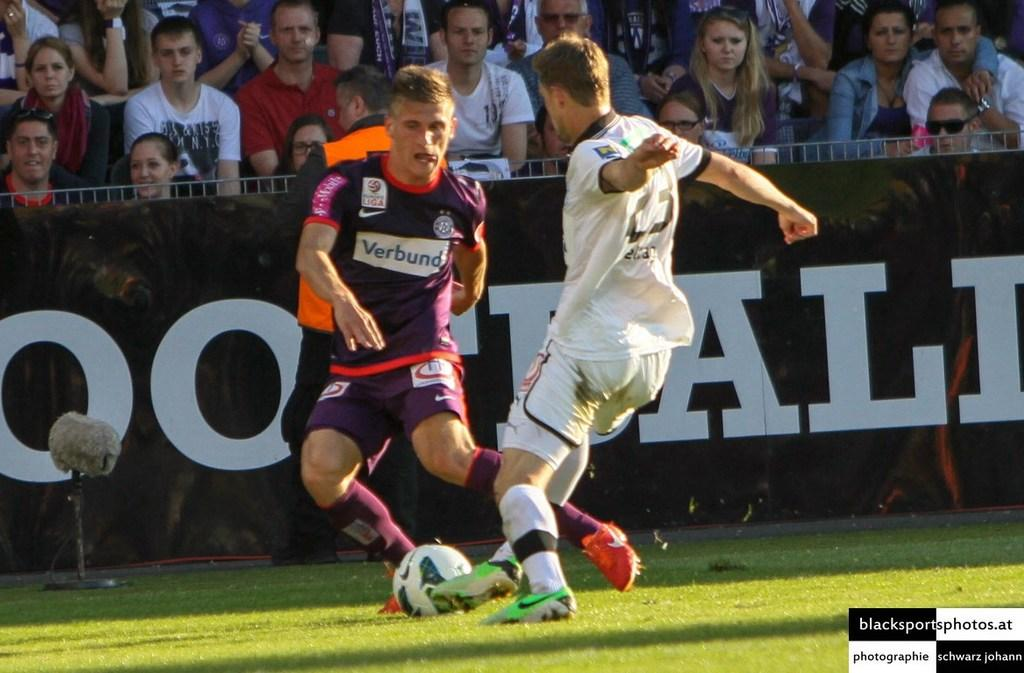<image>
Create a compact narrative representing the image presented. A soccer game, two players from opposite teams are disputing the ball one is wearing a purple jersey with a Verbund advertisement on it. 